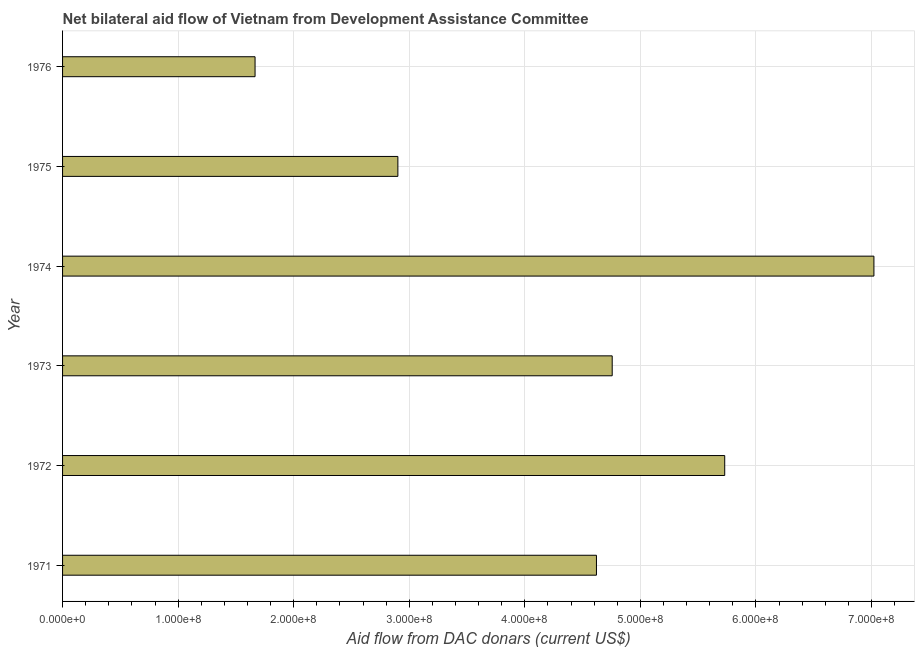Does the graph contain grids?
Provide a short and direct response. Yes. What is the title of the graph?
Your answer should be very brief. Net bilateral aid flow of Vietnam from Development Assistance Committee. What is the label or title of the X-axis?
Give a very brief answer. Aid flow from DAC donars (current US$). What is the label or title of the Y-axis?
Your answer should be compact. Year. What is the net bilateral aid flows from dac donors in 1973?
Provide a succinct answer. 4.76e+08. Across all years, what is the maximum net bilateral aid flows from dac donors?
Your answer should be compact. 7.02e+08. Across all years, what is the minimum net bilateral aid flows from dac donors?
Your response must be concise. 1.67e+08. In which year was the net bilateral aid flows from dac donors maximum?
Provide a succinct answer. 1974. In which year was the net bilateral aid flows from dac donors minimum?
Offer a terse response. 1976. What is the sum of the net bilateral aid flows from dac donors?
Keep it short and to the point. 2.67e+09. What is the difference between the net bilateral aid flows from dac donors in 1975 and 1976?
Your answer should be compact. 1.24e+08. What is the average net bilateral aid flows from dac donors per year?
Provide a short and direct response. 4.45e+08. What is the median net bilateral aid flows from dac donors?
Offer a terse response. 4.69e+08. Do a majority of the years between 1976 and 1975 (inclusive) have net bilateral aid flows from dac donors greater than 640000000 US$?
Provide a short and direct response. No. What is the ratio of the net bilateral aid flows from dac donors in 1973 to that in 1974?
Your response must be concise. 0.68. Is the difference between the net bilateral aid flows from dac donors in 1971 and 1972 greater than the difference between any two years?
Your response must be concise. No. What is the difference between the highest and the second highest net bilateral aid flows from dac donors?
Offer a terse response. 1.29e+08. Is the sum of the net bilateral aid flows from dac donors in 1974 and 1976 greater than the maximum net bilateral aid flows from dac donors across all years?
Your answer should be very brief. Yes. What is the difference between the highest and the lowest net bilateral aid flows from dac donors?
Your answer should be compact. 5.36e+08. In how many years, is the net bilateral aid flows from dac donors greater than the average net bilateral aid flows from dac donors taken over all years?
Offer a terse response. 4. How many years are there in the graph?
Provide a succinct answer. 6. What is the difference between two consecutive major ticks on the X-axis?
Your answer should be very brief. 1.00e+08. What is the Aid flow from DAC donars (current US$) in 1971?
Provide a short and direct response. 4.62e+08. What is the Aid flow from DAC donars (current US$) in 1972?
Offer a very short reply. 5.73e+08. What is the Aid flow from DAC donars (current US$) of 1973?
Your response must be concise. 4.76e+08. What is the Aid flow from DAC donars (current US$) of 1974?
Make the answer very short. 7.02e+08. What is the Aid flow from DAC donars (current US$) of 1975?
Provide a succinct answer. 2.90e+08. What is the Aid flow from DAC donars (current US$) of 1976?
Provide a succinct answer. 1.67e+08. What is the difference between the Aid flow from DAC donars (current US$) in 1971 and 1972?
Your answer should be very brief. -1.11e+08. What is the difference between the Aid flow from DAC donars (current US$) in 1971 and 1973?
Provide a succinct answer. -1.36e+07. What is the difference between the Aid flow from DAC donars (current US$) in 1971 and 1974?
Give a very brief answer. -2.40e+08. What is the difference between the Aid flow from DAC donars (current US$) in 1971 and 1975?
Offer a terse response. 1.72e+08. What is the difference between the Aid flow from DAC donars (current US$) in 1971 and 1976?
Keep it short and to the point. 2.95e+08. What is the difference between the Aid flow from DAC donars (current US$) in 1972 and 1973?
Provide a short and direct response. 9.74e+07. What is the difference between the Aid flow from DAC donars (current US$) in 1972 and 1974?
Ensure brevity in your answer.  -1.29e+08. What is the difference between the Aid flow from DAC donars (current US$) in 1972 and 1975?
Make the answer very short. 2.83e+08. What is the difference between the Aid flow from DAC donars (current US$) in 1972 and 1976?
Make the answer very short. 4.06e+08. What is the difference between the Aid flow from DAC donars (current US$) in 1973 and 1974?
Keep it short and to the point. -2.26e+08. What is the difference between the Aid flow from DAC donars (current US$) in 1973 and 1975?
Give a very brief answer. 1.85e+08. What is the difference between the Aid flow from DAC donars (current US$) in 1973 and 1976?
Your answer should be compact. 3.09e+08. What is the difference between the Aid flow from DAC donars (current US$) in 1974 and 1975?
Ensure brevity in your answer.  4.12e+08. What is the difference between the Aid flow from DAC donars (current US$) in 1974 and 1976?
Provide a short and direct response. 5.36e+08. What is the difference between the Aid flow from DAC donars (current US$) in 1975 and 1976?
Offer a very short reply. 1.24e+08. What is the ratio of the Aid flow from DAC donars (current US$) in 1971 to that in 1972?
Keep it short and to the point. 0.81. What is the ratio of the Aid flow from DAC donars (current US$) in 1971 to that in 1973?
Your answer should be very brief. 0.97. What is the ratio of the Aid flow from DAC donars (current US$) in 1971 to that in 1974?
Your answer should be compact. 0.66. What is the ratio of the Aid flow from DAC donars (current US$) in 1971 to that in 1975?
Give a very brief answer. 1.59. What is the ratio of the Aid flow from DAC donars (current US$) in 1971 to that in 1976?
Keep it short and to the point. 2.77. What is the ratio of the Aid flow from DAC donars (current US$) in 1972 to that in 1973?
Keep it short and to the point. 1.21. What is the ratio of the Aid flow from DAC donars (current US$) in 1972 to that in 1974?
Provide a short and direct response. 0.82. What is the ratio of the Aid flow from DAC donars (current US$) in 1972 to that in 1975?
Your answer should be compact. 1.98. What is the ratio of the Aid flow from DAC donars (current US$) in 1972 to that in 1976?
Your answer should be very brief. 3.44. What is the ratio of the Aid flow from DAC donars (current US$) in 1973 to that in 1974?
Your answer should be very brief. 0.68. What is the ratio of the Aid flow from DAC donars (current US$) in 1973 to that in 1975?
Your response must be concise. 1.64. What is the ratio of the Aid flow from DAC donars (current US$) in 1973 to that in 1976?
Give a very brief answer. 2.85. What is the ratio of the Aid flow from DAC donars (current US$) in 1974 to that in 1975?
Your answer should be very brief. 2.42. What is the ratio of the Aid flow from DAC donars (current US$) in 1974 to that in 1976?
Offer a very short reply. 4.21. What is the ratio of the Aid flow from DAC donars (current US$) in 1975 to that in 1976?
Give a very brief answer. 1.74. 